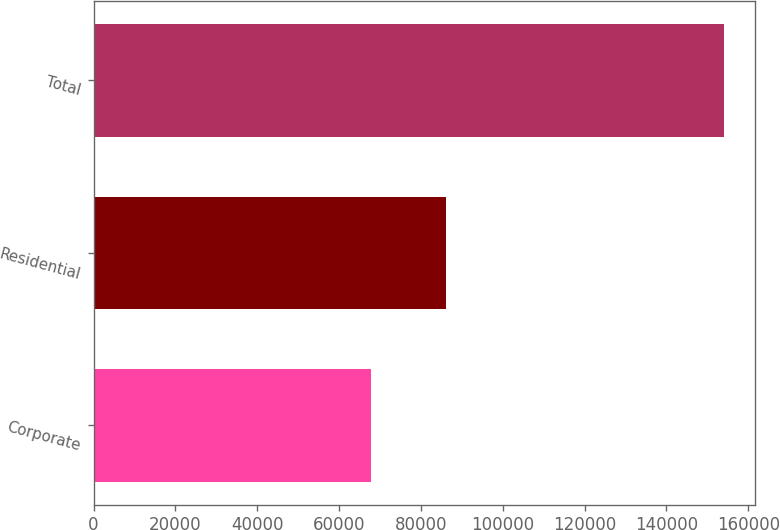Convert chart. <chart><loc_0><loc_0><loc_500><loc_500><bar_chart><fcel>Corporate<fcel>Residential<fcel>Total<nl><fcel>67901<fcel>86082<fcel>153983<nl></chart> 